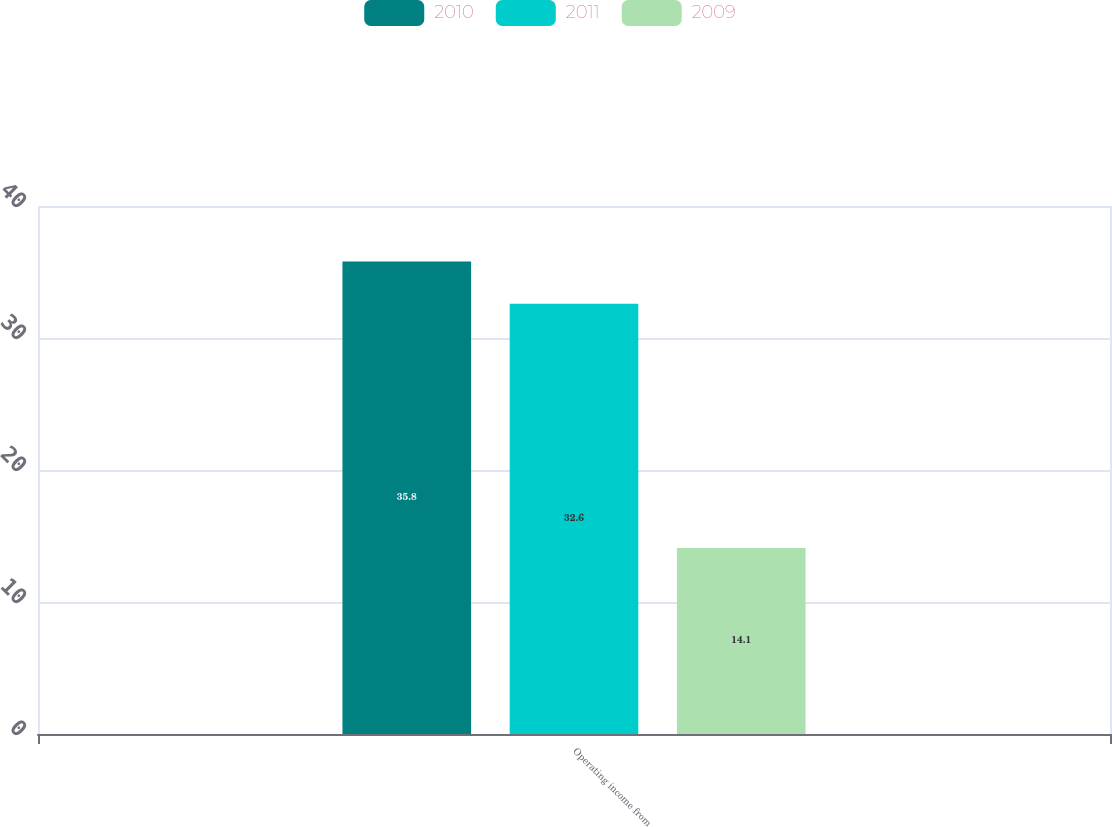<chart> <loc_0><loc_0><loc_500><loc_500><stacked_bar_chart><ecel><fcel>Operating income from<nl><fcel>2010<fcel>35.8<nl><fcel>2011<fcel>32.6<nl><fcel>2009<fcel>14.1<nl></chart> 